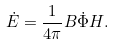<formula> <loc_0><loc_0><loc_500><loc_500>\dot { E } = \frac { 1 } { 4 \pi } { B \dot { \Phi } H } .</formula> 